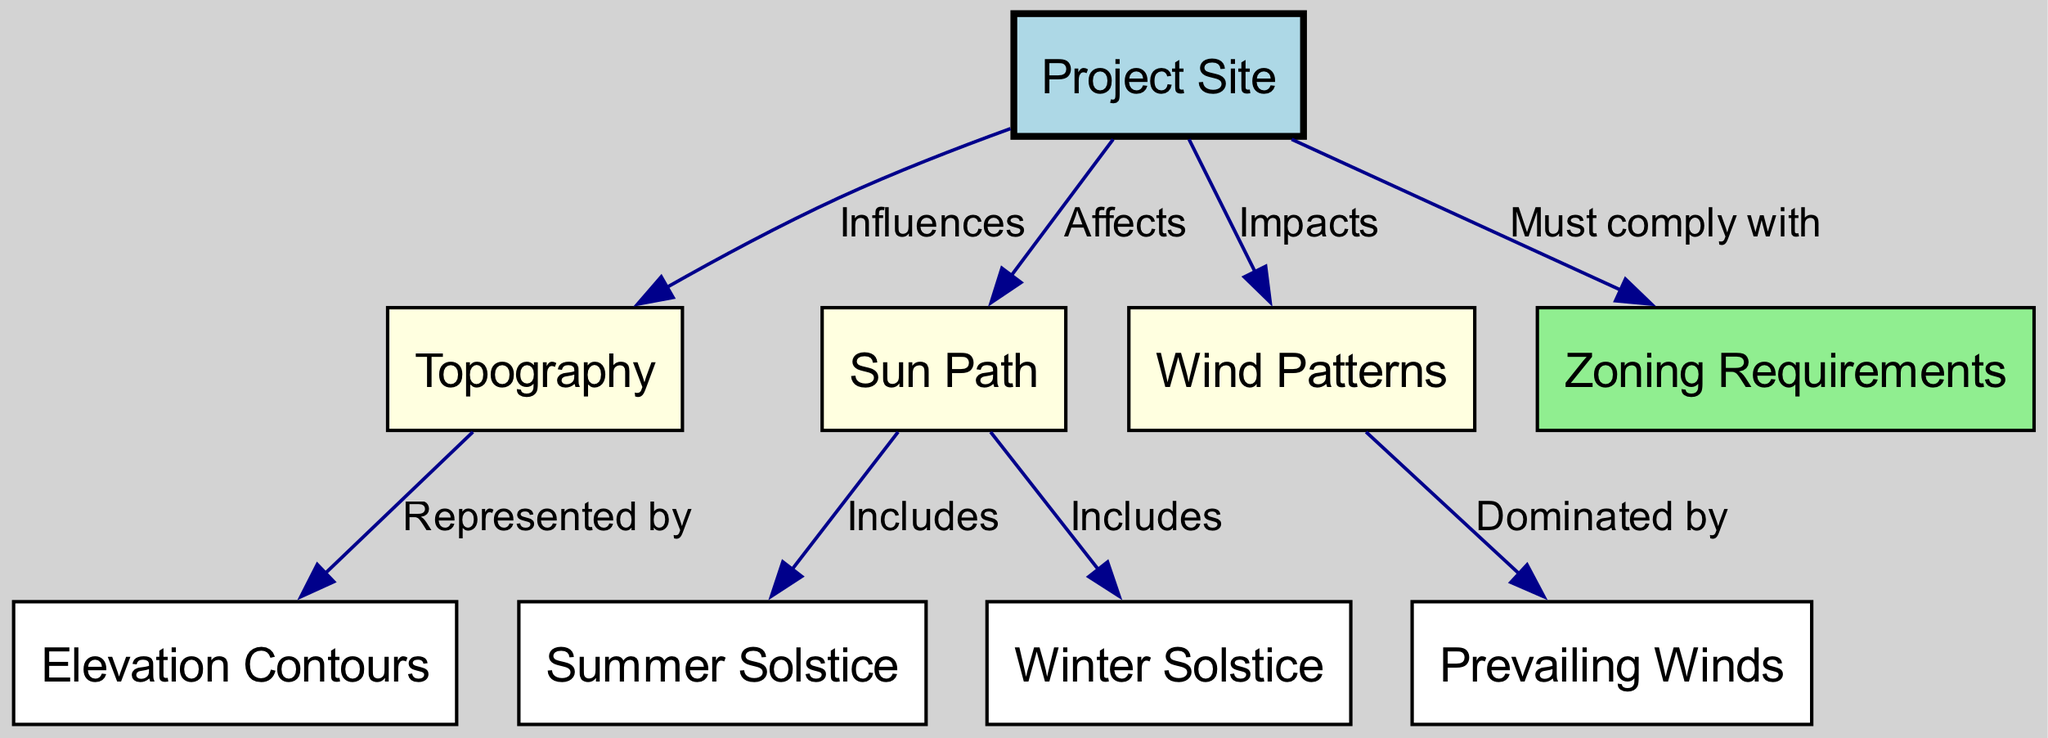What is the total number of nodes in the diagram? The diagram lists the nodes which include 'Project Site', 'Topography', 'Sun Path', 'Wind Patterns', 'Zoning Requirements', 'Elevation Contours', 'Summer Solstice', 'Winter Solstice', and 'Prevailing Winds'. Counting these gives a total of nine nodes.
Answer: 9 What edge connects 'Site' to 'Topography'? The edge between 'Site' and 'Topography' is labeled 'Influences', indicating that the site influences the topography of the area.
Answer: Influences Which node represents topography details by elevation? The node 'Elevation Contours' is connected to the 'Topography' node with the label 'Represented by', hence it represents the details of topography as elevation.
Answer: Elevation Contours How many edges are connected to the 'Wind Patterns' node? Analyzing the edges, 'Wind Patterns' has two connections: one to 'Site' with 'Impacts' and one to 'Prevailing Winds' with 'Dominated by', thus there are two edges connected to it.
Answer: 2 What are the included solstices in the 'Sun Path'? The 'Sun Path' node includes two solstices: 'Summer Solstice' and 'Winter Solstice', which are explicitly connected to it.
Answer: Summer Solstice and Winter Solstice How does 'Zoning Requirements' relate to 'Site'? 'Zoning Requirements' is connected to 'Site' by the label 'Must comply with', indicating that the project site must adhere to specific zoning requirements.
Answer: Must comply with What influences the relationship between 'Topography' and 'Elevation'? The 'Topography' influences the 'Elevation Contours', described by the edge label 'Represented by', showing that topographic features determine elevation lines.
Answer: Represented by What do 'Prevailing Winds' indicate in relation to 'Wind Patterns'? 'Wind Patterns' is dominated by 'Prevailing Winds', as shown by the edge labeled 'Dominated by', which describes how the wind patterns are influenced.
Answer: Dominated by Which aspect must a project site consider regarding its relationship to sun exposure? The project site must consider the 'Sun Path', as it directly affects the placement and design of structures for optimal sunlight exposure.
Answer: Sun Path 